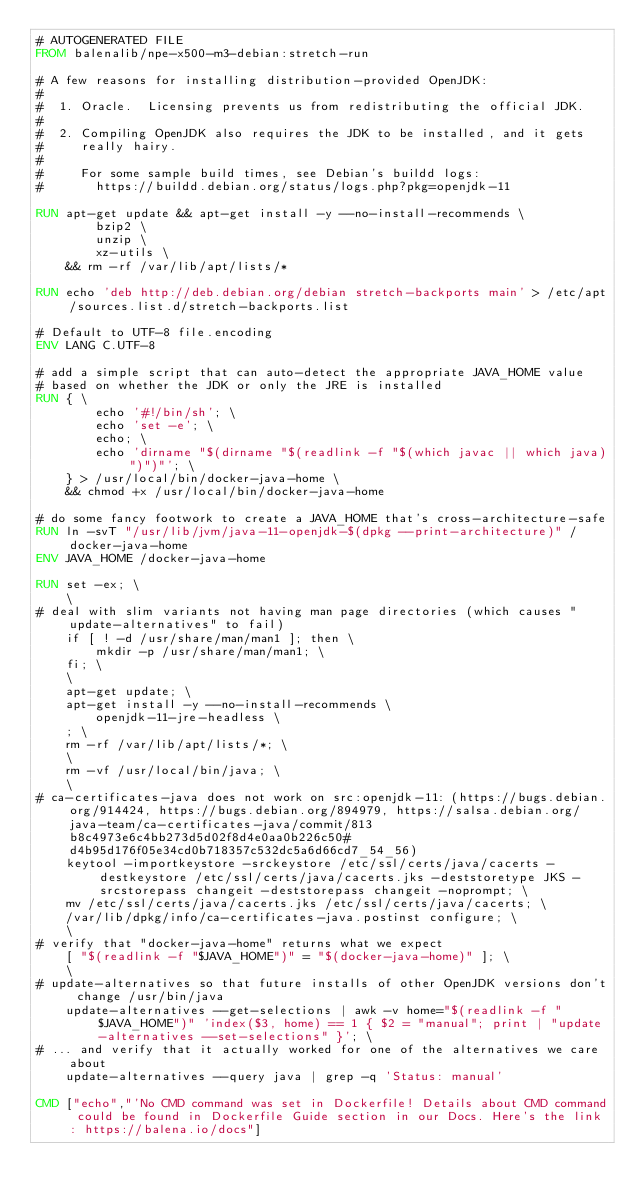<code> <loc_0><loc_0><loc_500><loc_500><_Dockerfile_># AUTOGENERATED FILE
FROM balenalib/npe-x500-m3-debian:stretch-run

# A few reasons for installing distribution-provided OpenJDK:
#
#  1. Oracle.  Licensing prevents us from redistributing the official JDK.
#
#  2. Compiling OpenJDK also requires the JDK to be installed, and it gets
#     really hairy.
#
#     For some sample build times, see Debian's buildd logs:
#       https://buildd.debian.org/status/logs.php?pkg=openjdk-11

RUN apt-get update && apt-get install -y --no-install-recommends \
		bzip2 \
		unzip \
		xz-utils \
	&& rm -rf /var/lib/apt/lists/*

RUN echo 'deb http://deb.debian.org/debian stretch-backports main' > /etc/apt/sources.list.d/stretch-backports.list

# Default to UTF-8 file.encoding
ENV LANG C.UTF-8

# add a simple script that can auto-detect the appropriate JAVA_HOME value
# based on whether the JDK or only the JRE is installed
RUN { \
		echo '#!/bin/sh'; \
		echo 'set -e'; \
		echo; \
		echo 'dirname "$(dirname "$(readlink -f "$(which javac || which java)")")"'; \
	} > /usr/local/bin/docker-java-home \
	&& chmod +x /usr/local/bin/docker-java-home

# do some fancy footwork to create a JAVA_HOME that's cross-architecture-safe
RUN ln -svT "/usr/lib/jvm/java-11-openjdk-$(dpkg --print-architecture)" /docker-java-home
ENV JAVA_HOME /docker-java-home

RUN set -ex; \
	\
# deal with slim variants not having man page directories (which causes "update-alternatives" to fail)
	if [ ! -d /usr/share/man/man1 ]; then \
		mkdir -p /usr/share/man/man1; \
	fi; \
	\
	apt-get update; \
	apt-get install -y --no-install-recommends \
		openjdk-11-jre-headless \
	; \
	rm -rf /var/lib/apt/lists/*; \
	\
	rm -vf /usr/local/bin/java; \
	\
# ca-certificates-java does not work on src:openjdk-11: (https://bugs.debian.org/914424, https://bugs.debian.org/894979, https://salsa.debian.org/java-team/ca-certificates-java/commit/813b8c4973e6c4bb273d5d02f8d4e0aa0b226c50#d4b95d176f05e34cd0b718357c532dc5a6d66cd7_54_56)
	keytool -importkeystore -srckeystore /etc/ssl/certs/java/cacerts -destkeystore /etc/ssl/certs/java/cacerts.jks -deststoretype JKS -srcstorepass changeit -deststorepass changeit -noprompt; \
	mv /etc/ssl/certs/java/cacerts.jks /etc/ssl/certs/java/cacerts; \
	/var/lib/dpkg/info/ca-certificates-java.postinst configure; \
	\
# verify that "docker-java-home" returns what we expect
	[ "$(readlink -f "$JAVA_HOME")" = "$(docker-java-home)" ]; \
	\
# update-alternatives so that future installs of other OpenJDK versions don't change /usr/bin/java
	update-alternatives --get-selections | awk -v home="$(readlink -f "$JAVA_HOME")" 'index($3, home) == 1 { $2 = "manual"; print | "update-alternatives --set-selections" }'; \
# ... and verify that it actually worked for one of the alternatives we care about
	update-alternatives --query java | grep -q 'Status: manual'

CMD ["echo","'No CMD command was set in Dockerfile! Details about CMD command could be found in Dockerfile Guide section in our Docs. Here's the link: https://balena.io/docs"]
</code> 